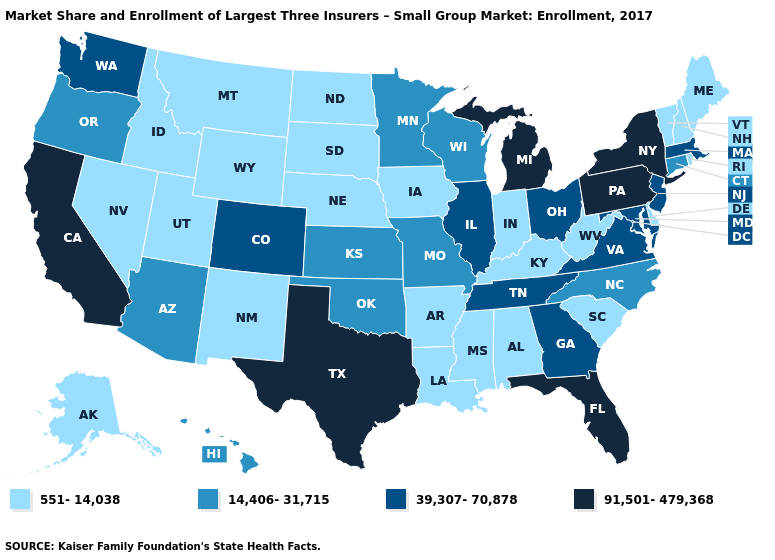Which states hav the highest value in the South?
Give a very brief answer. Florida, Texas. Name the states that have a value in the range 39,307-70,878?
Keep it brief. Colorado, Georgia, Illinois, Maryland, Massachusetts, New Jersey, Ohio, Tennessee, Virginia, Washington. What is the highest value in states that border Vermont?
Quick response, please. 91,501-479,368. What is the value of Massachusetts?
Short answer required. 39,307-70,878. What is the value of Idaho?
Answer briefly. 551-14,038. Does Mississippi have the same value as North Dakota?
Quick response, please. Yes. What is the value of Oregon?
Be succinct. 14,406-31,715. Which states have the lowest value in the USA?
Write a very short answer. Alabama, Alaska, Arkansas, Delaware, Idaho, Indiana, Iowa, Kentucky, Louisiana, Maine, Mississippi, Montana, Nebraska, Nevada, New Hampshire, New Mexico, North Dakota, Rhode Island, South Carolina, South Dakota, Utah, Vermont, West Virginia, Wyoming. Which states have the highest value in the USA?
Be succinct. California, Florida, Michigan, New York, Pennsylvania, Texas. Among the states that border Connecticut , which have the lowest value?
Keep it brief. Rhode Island. Does Ohio have the lowest value in the USA?
Answer briefly. No. Name the states that have a value in the range 551-14,038?
Keep it brief. Alabama, Alaska, Arkansas, Delaware, Idaho, Indiana, Iowa, Kentucky, Louisiana, Maine, Mississippi, Montana, Nebraska, Nevada, New Hampshire, New Mexico, North Dakota, Rhode Island, South Carolina, South Dakota, Utah, Vermont, West Virginia, Wyoming. Among the states that border Kentucky , does Indiana have the lowest value?
Short answer required. Yes. Name the states that have a value in the range 39,307-70,878?
Write a very short answer. Colorado, Georgia, Illinois, Maryland, Massachusetts, New Jersey, Ohio, Tennessee, Virginia, Washington. Does Alaska have a lower value than Oregon?
Quick response, please. Yes. 